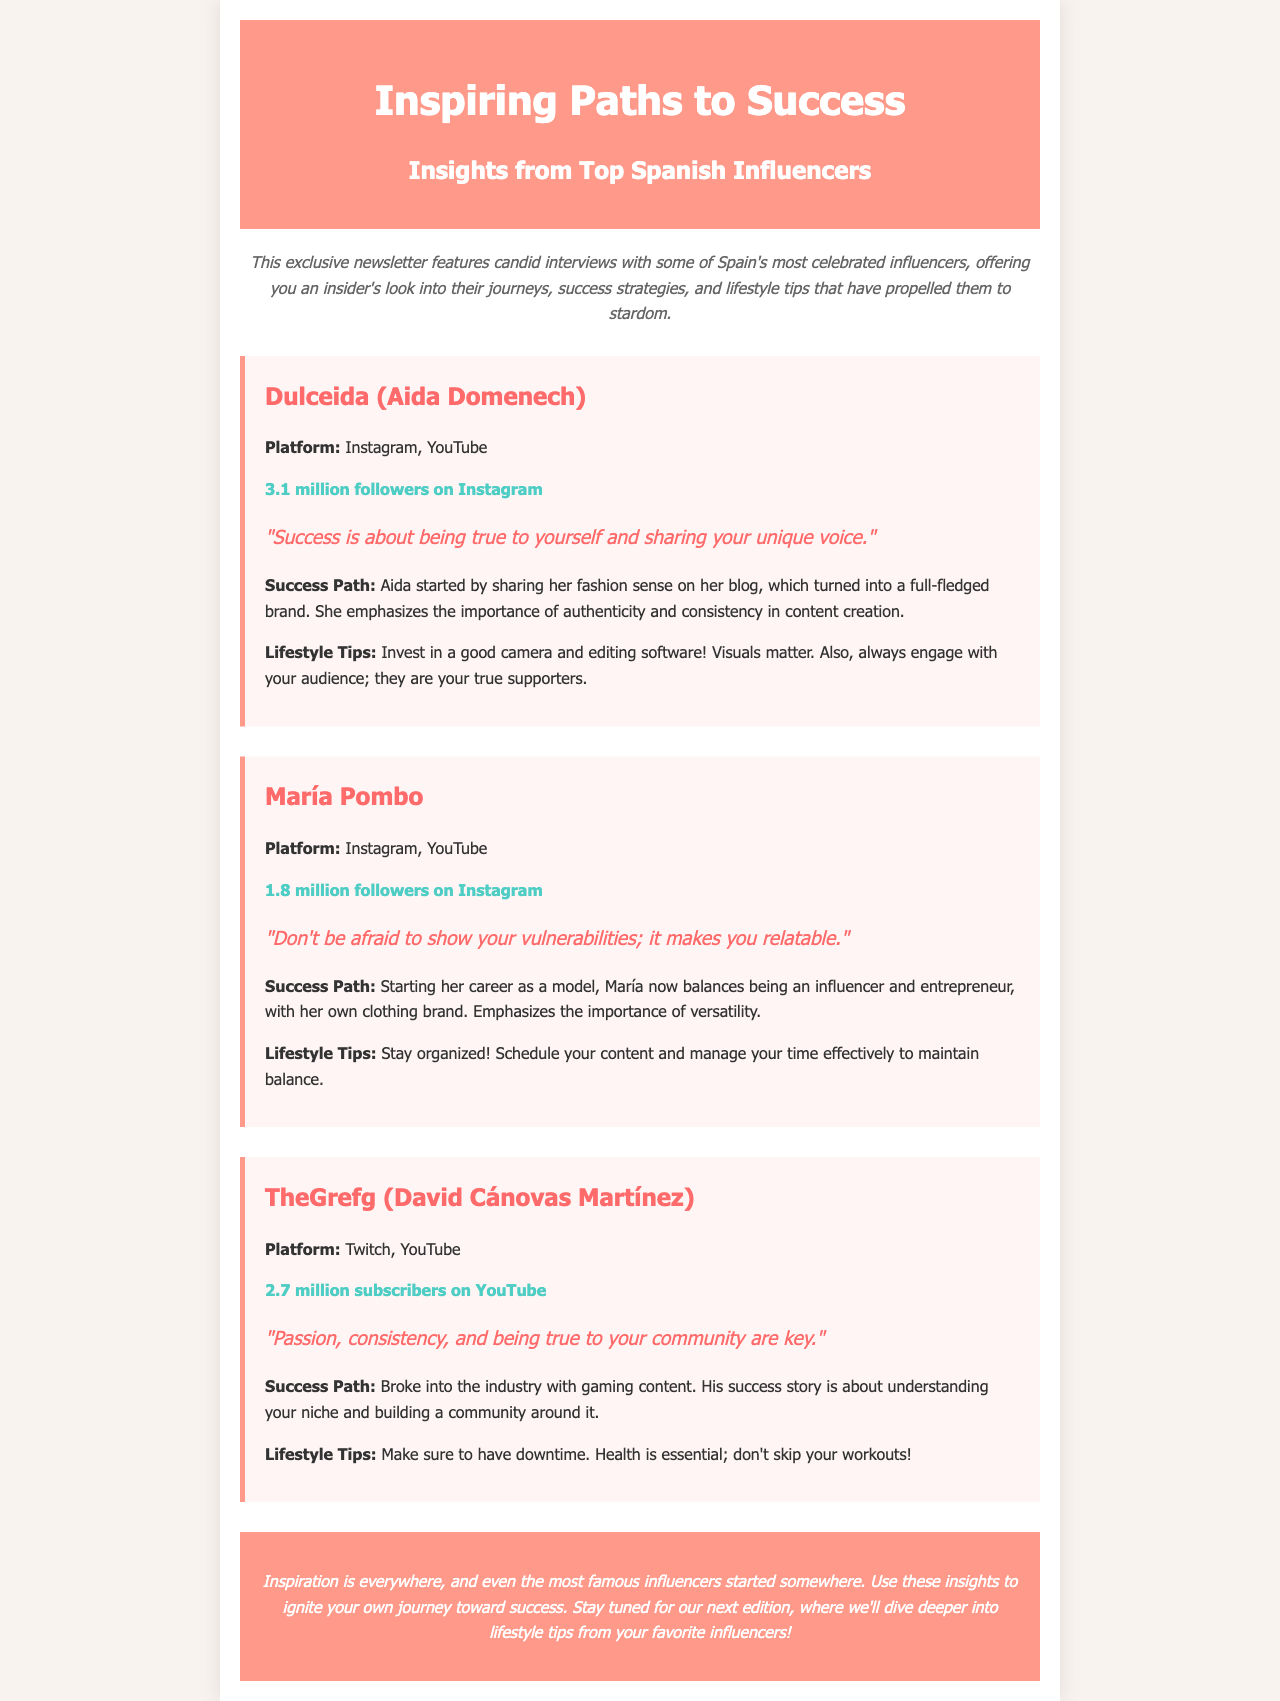What is the title of the newsletter? The title of the newsletter is presented prominently at the top of the document.
Answer: Inspiring Paths to Success: Insights from Top Spanish Influencers Who is the first influencer interviewed in the newsletter? The first influencer mentioned in the document is highlighted in a specific section dedicated to her.
Answer: Dulceida (Aida Domenech) How many followers does María Pombo have on Instagram? The document specifically states the number of followers for María Pombo in her interview section.
Answer: 1.8 million followers What is TheGrefg's primary platform? The document indicates TheGrefg's primary platform within the interview section he is featured in.
Answer: Twitch, YouTube What is a common theme in the success paths of the influencers? The success paths of the influencers in the document emphasize a key aspect that resonates across their interviews.
Answer: Authenticity Which influencer emphasizes staying organized? The interview with this influencer specifically mentions the importance of organization in managing time.
Answer: María Pombo What lifestyle tip does Dulceida provide? The lifestyle tip given by Dulceida is noted as a piece of advice in her section.
Answer: Invest in a good camera and editing software How many subscribers does TheGrefg have on YouTube? The number of subscribers for TheGrefg is mentioned in the interview section dedicated to him.
Answer: 2.7 million subscribers What color is the background of the document? The background color is described in the styling section of the document.
Answer: #f9f3f0 